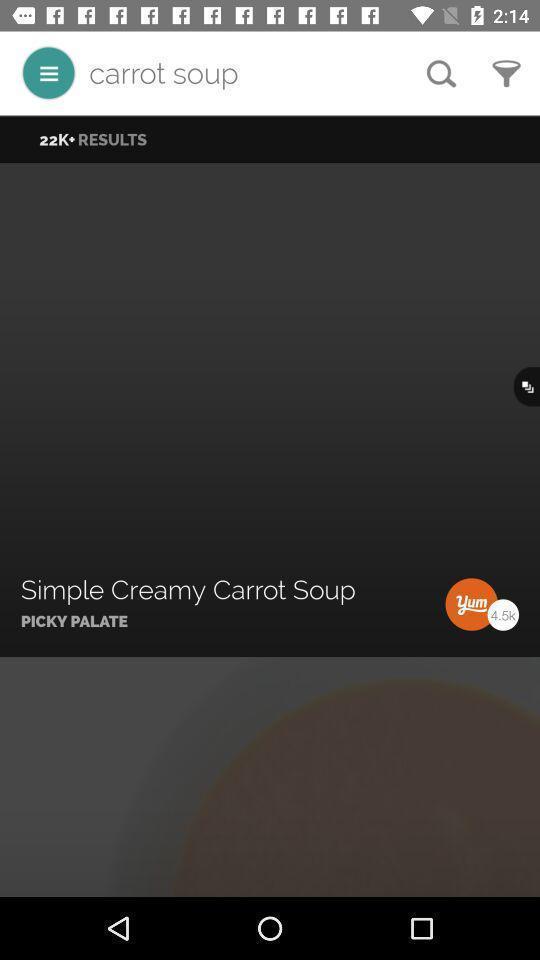Give me a summary of this screen capture. Search bar to find different recipes. 